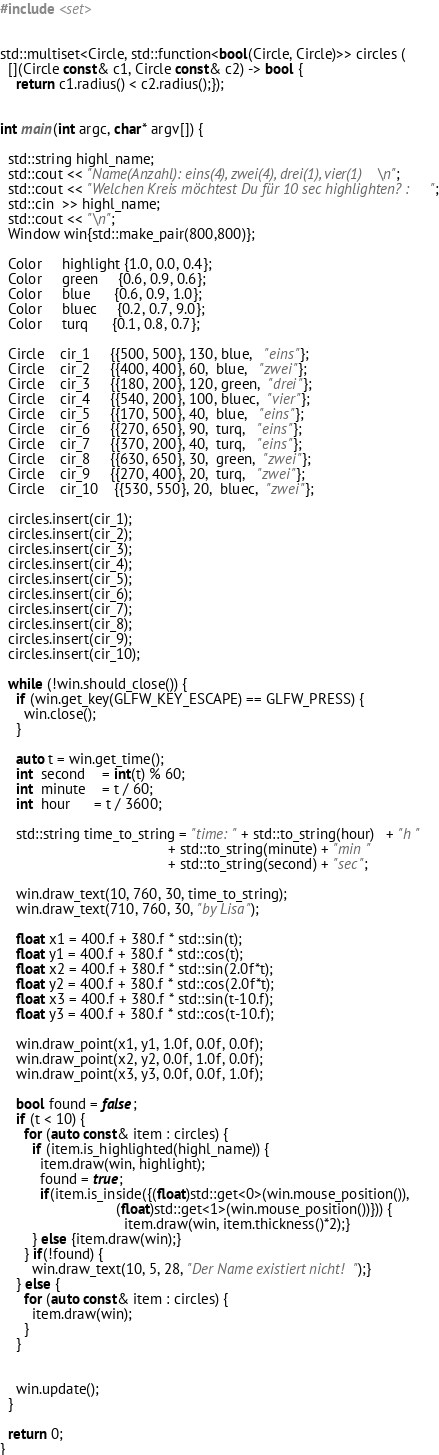Convert code to text. <code><loc_0><loc_0><loc_500><loc_500><_C++_>#include <set>


std::multiset<Circle, std::function<bool(Circle, Circle)>> circles (
  [](Circle const& c1, Circle const& c2) -> bool { 
    return c1.radius() < c2.radius();});


int main(int argc, char* argv[]) {

  std::string highl_name;
  std::cout << "Name(Anzahl): eins(4), zwei(4), drei(1), vier(1)\n";
  std::cout << "Welchen Kreis möchtest Du für 10 sec highlighten? : ";
  std::cin  >> highl_name;
  std::cout << "\n";
  Window win{std::make_pair(800,800)};

  Color     highlight {1.0, 0.0, 0.4};
  Color     green     {0.6, 0.9, 0.6};
  Color     blue      {0.6, 0.9, 1.0};
  Color     bluec     {0.2, 0.7, 9.0};
  Color     turq      {0.1, 0.8, 0.7};

  Circle    cir_1     {{500, 500}, 130, blue,   "eins"};
  Circle    cir_2     {{400, 400}, 60,  blue,   "zwei"};
  Circle    cir_3     {{180, 200}, 120, green,  "drei"};
  Circle    cir_4     {{540, 200}, 100, bluec,  "vier"};
  Circle    cir_5     {{170, 500}, 40,  blue,   "eins"};
  Circle    cir_6     {{270, 650}, 90,  turq,   "eins"};
  Circle    cir_7     {{370, 200}, 40,  turq,   "eins"};
  Circle    cir_8     {{630, 650}, 30,  green,  "zwei"};
  Circle    cir_9     {{270, 400}, 20,  turq,   "zwei"};
  Circle    cir_10    {{530, 550}, 20,  bluec,  "zwei"};

  circles.insert(cir_1);
  circles.insert(cir_2);
  circles.insert(cir_3);
  circles.insert(cir_4);
  circles.insert(cir_5);
  circles.insert(cir_6);
  circles.insert(cir_7);
  circles.insert(cir_8);
  circles.insert(cir_9);
  circles.insert(cir_10);

  while (!win.should_close()) {
    if (win.get_key(GLFW_KEY_ESCAPE) == GLFW_PRESS) {
      win.close();
    }

    auto t = win.get_time();
    int  second    = int(t) % 60;
    int  minute    = t / 60;
    int  hour      = t / 3600;

    std::string time_to_string = "time: " + std::to_string(hour)   + "h " 
                                          + std::to_string(minute) + "min "
                                          + std::to_string(second) + "sec";

    win.draw_text(10, 760, 30, time_to_string);
    win.draw_text(710, 760, 30, "by Lisa");

    float x1 = 400.f + 380.f * std::sin(t);
    float y1 = 400.f + 380.f * std::cos(t);
    float x2 = 400.f + 380.f * std::sin(2.0f*t);
    float y2 = 400.f + 380.f * std::cos(2.0f*t);
    float x3 = 400.f + 380.f * std::sin(t-10.f);
    float y3 = 400.f + 380.f * std::cos(t-10.f);

    win.draw_point(x1, y1, 1.0f, 0.0f, 0.0f);
    win.draw_point(x2, y2, 0.0f, 1.0f, 0.0f);
    win.draw_point(x3, y3, 0.0f, 0.0f, 1.0f);

    bool found = false;
    if (t < 10) {
      for (auto const& item : circles) {
        if (item.is_highlighted(highl_name)) {
          item.draw(win, highlight);
          found = true;
          if(item.is_inside({(float)std::get<0>(win.mouse_position()), 
                             (float)std::get<1>(win.mouse_position())})) {
                               item.draw(win, item.thickness()*2);}   
        } else {item.draw(win);}
      } if(!found) { 
        win.draw_text(10, 5, 28, "Der Name existiert nicht!");}
    } else {
      for (auto const& item : circles) {
        item.draw(win);
      }
    }


    win.update();
  }

  return 0;
}

</code> 